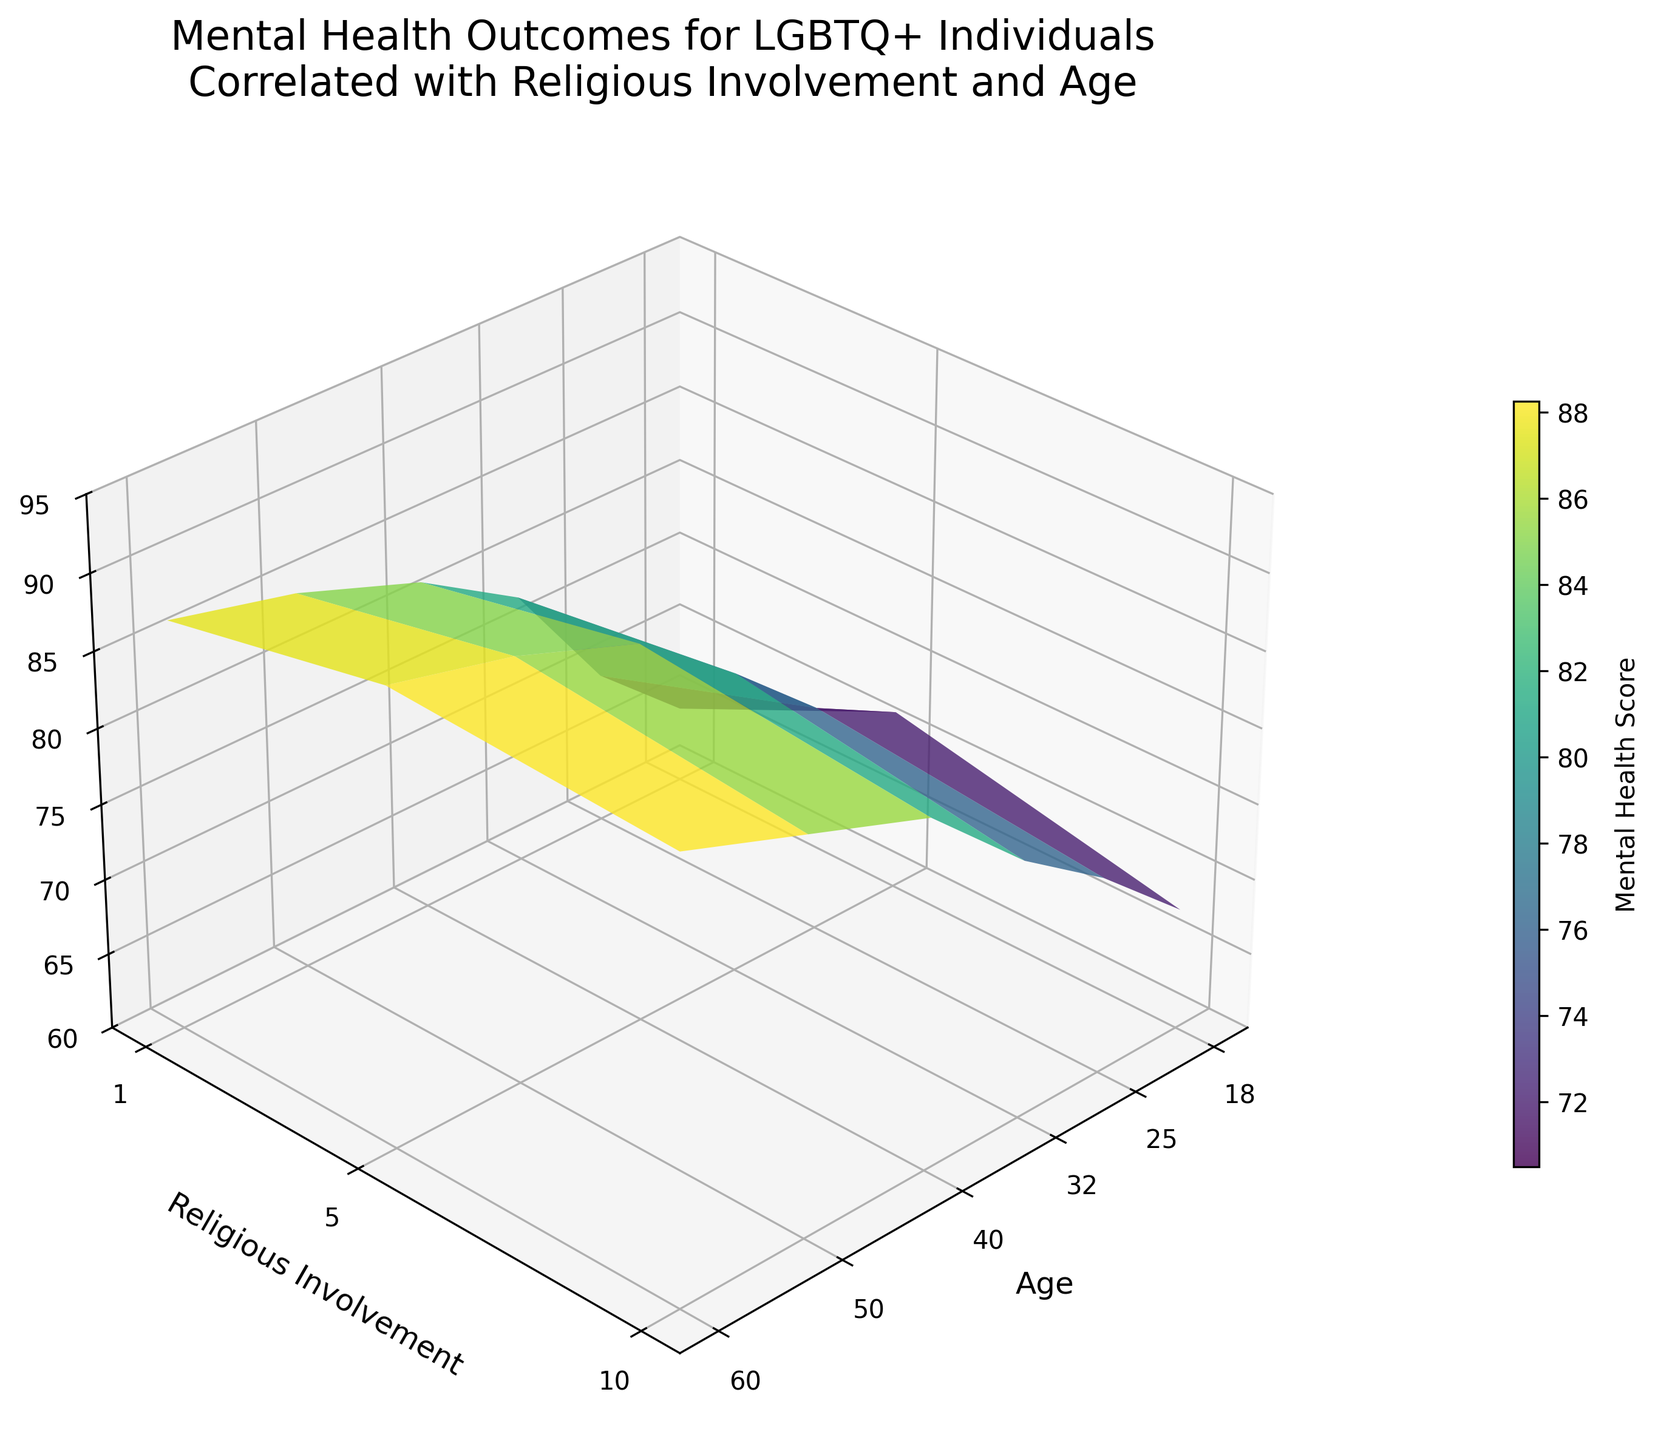What's the title of the figure? The title is usually placed at the top of the figure. The title of this figure is "Mental Health Outcomes for LGBTQ+ Individuals Correlated with Religious Involvement and Age."
Answer: Mental Health Outcomes for LGBTQ+ Individuals Correlated with Religious Involvement and Age What are the axis labels in the figure? Look at the text labels along each axis. The x-axis is labeled 'Age', the y-axis is labeled 'Religious Involvement', and the z-axis is labeled 'Mental Health Score'.
Answer: Age, Religious Involvement, Mental Health Score At what age do we observe the highest mental health score? The highest mental health score can be found by looking at the peak of the surface plot. It occurs at age 60, with the highest religious involvement level.
Answer: 60 years old How does mental health score change with increased religious involvement at age 25? To answer this, observe the variation in mental health scores along the religious involvement axis for age 25 on the surface plot. The mental health score increases as religious involvement increases from 1 to 5 and then slightly decreases at 10.
Answer: Increases then slightly decreases What is the mental health score at age 32 and religious involvement level of 1? Locate the data point on the surface plot where age is 32 and religious involvement is 1. The mental health score is 78.
Answer: 78 Compare the mental health scores of individuals aged 18 with those aged 50. Which age group tends to have higher scores? To find the answer, compare the mental health scores along the surface plot for ages 18 and 50. The scores for age 50 are higher across all levels of religious involvement compared to age 18.
Answer: Aged 50 tends to have higher scores How does mental health score vary with age for people with a religious involvement level of 5? Observe the mental health scores on the surface plot for a constant religious involvement level of 5. As age increases, the mental health score also increases.
Answer: Increases Is there a general trend in mental health scores with age regardless of religious involvement? Examine the surface plot for a pattern along the age axis. Generally, mental health scores increase with age across all levels of religious involvement.
Answer: Increases with age What are the minimum and maximum mental health scores in the figure? The minimum and maximum scores are typically found at the extremes of the surface plot. The minimum score is 65, and the maximum score is 90.
Answer: Minimum: 65, Maximum: 90 At what combination of age and religious involvement do we see a mental health score of 85? Look for the point on the surface plot or the corresponding axis where the mental health score reaches 85. It occurs at age 40 with religious involvement level 5 and also at age 50 with religious involvement level 1.
Answer: Age 40 with religious involvement level 5; Age 50 with religious involvement level 1 